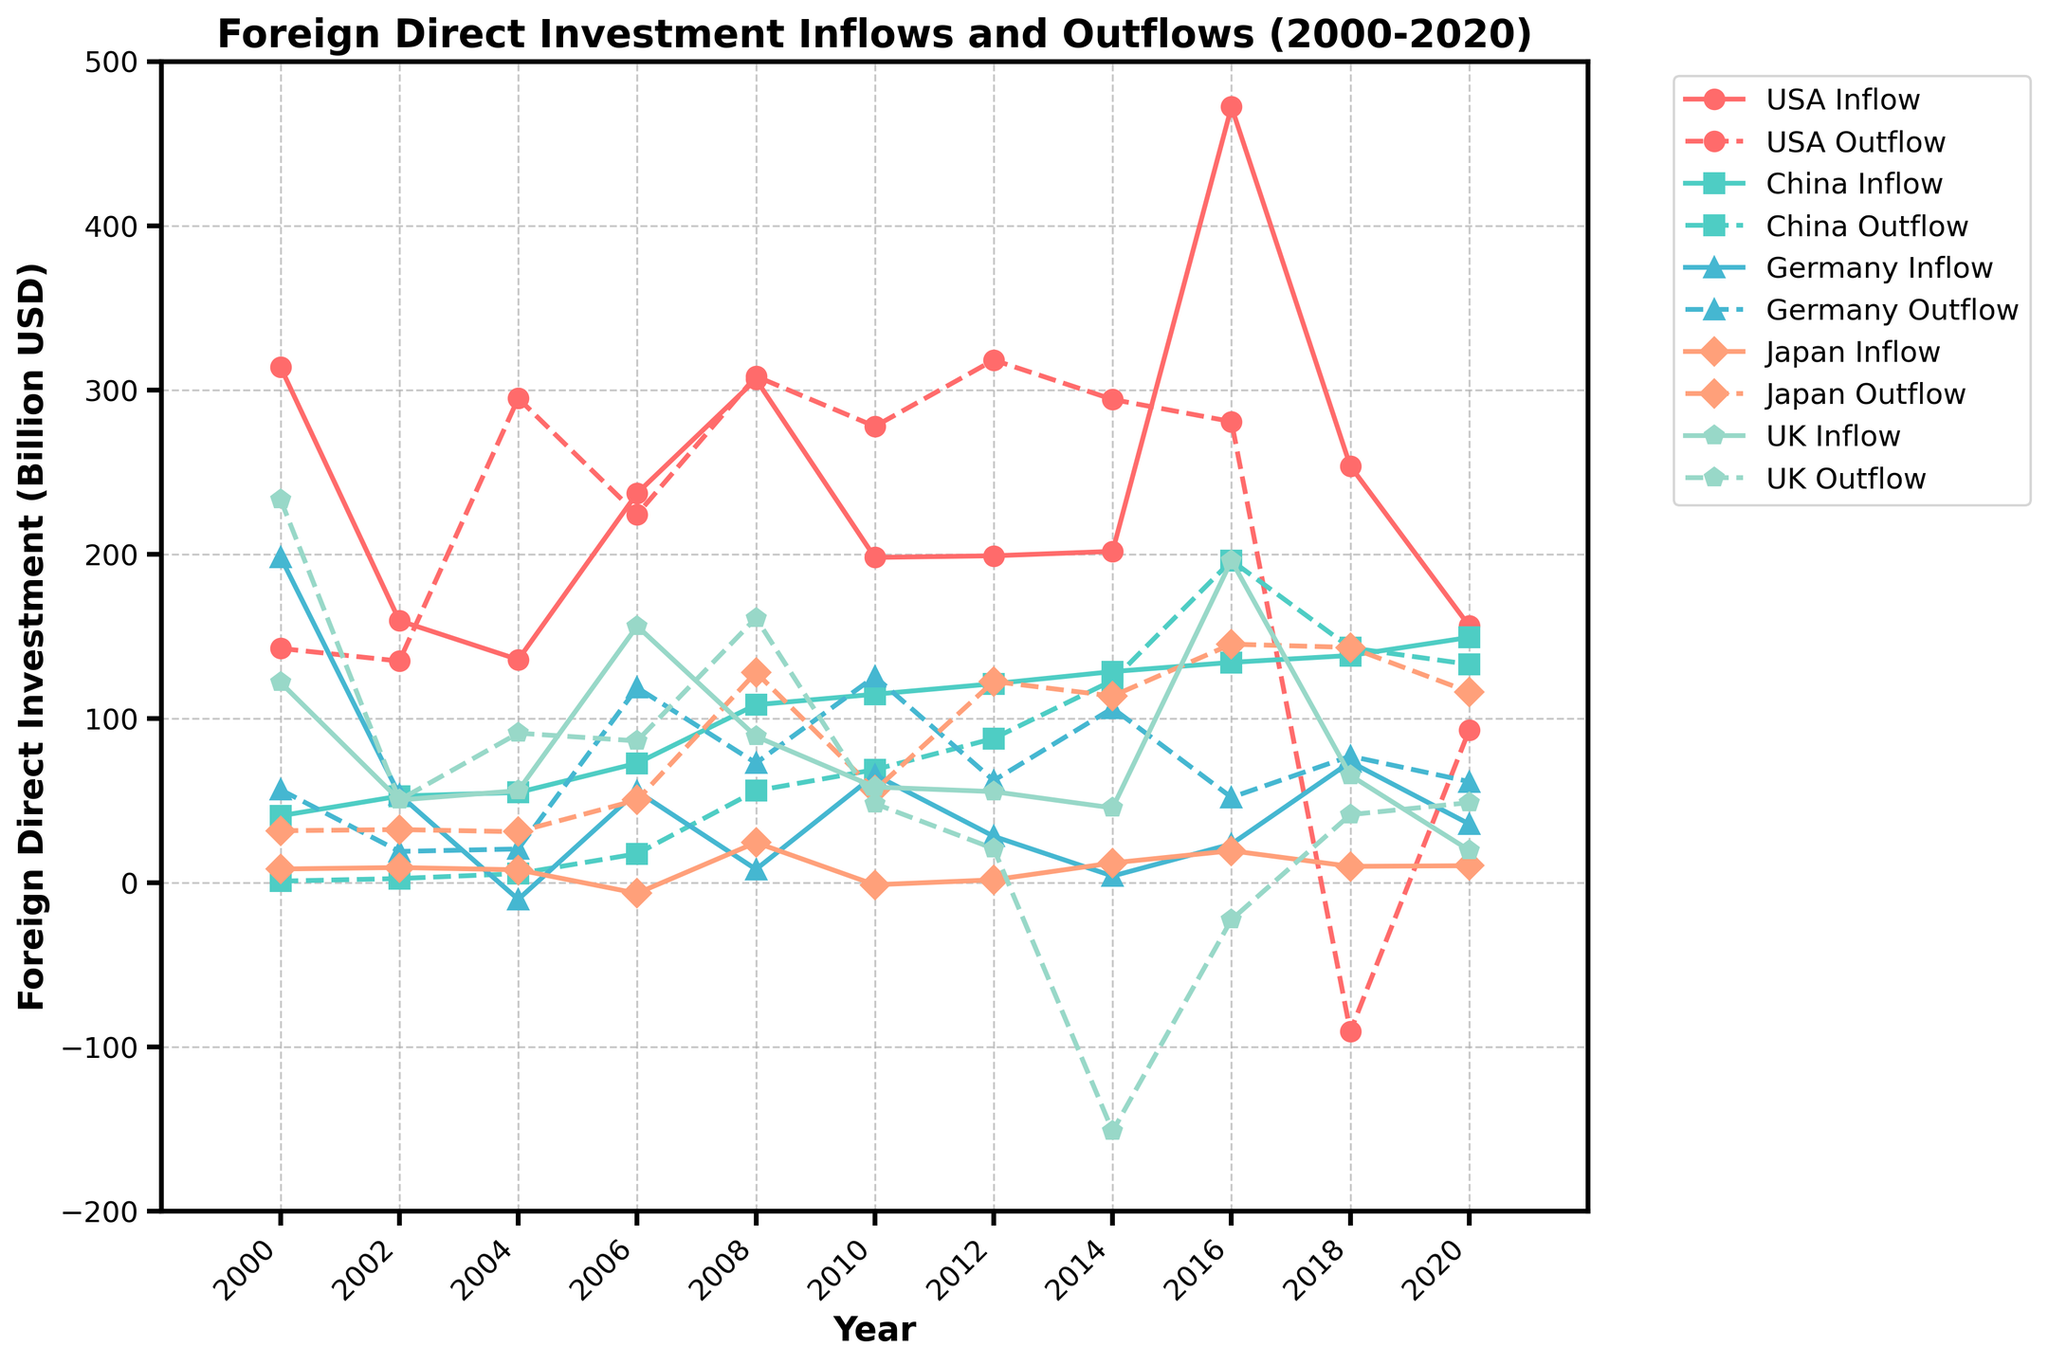What is the difference between the USA's FDI inflows and outflows in 2020? To find the difference between the USA's FDI inflows and outflows in 2020, we subtract the outflow value from the inflow value. Inflow is 156.3 Billion USD and outflow is 92.9 Billion USD. So, 156.3 - 92.9 = 63.4 Billion USD.
Answer: 63.4 Billion USD Which country had the highest FDI inflow in 2016? Looking at the 2016 data points, we compare the FDI inflows for each country: USA (472.4), China (134.1), Germany (23.5), Japan (19.4), and UK (196.1). The USA has the highest inflow with 472.4 Billion USD.
Answer: USA During which years did China have a higher outflow than inflow? We look for years where China's FDI outflow is greater than inflow by comparing values for each year: 
- In 2000 (0.9 < 40.7), the outflow is lower.
- In 2002 (2.5 < 52.7), the outflow is lower.
- In 2004 (5.5 < 54.9), the outflow is lower.
- In 2006 (17.6 < 72.7), the outflow is lower.
- In 2008 (55.9 < 108.3), the outflow is lower.
- In 2010 (68.8 < 114.7), the outflow is lower.
- In 2012 (87.8 < 121.1), the outflow is lower.
- In 2014 (123.1 < 128.5), the outflow is lower.
- In 2016 (196.1 > 134.1), the outflow is higher.
- In 2018 (143.0 > 138.3), the outflow is higher.
- In 2020 (132.9 < 149.3), the outflow is lower.
So, the years are 2016 and 2018.
Answer: 2016 and 2018 What is the average FDI inflow for Japan from 2000 to 2020? To find the average, we sum all the inflow values for Japan from 2000 to 2020 and divide by the total number of years (10):
(8.3 + 9.2 + 7.8 + -6.5 + 24.4 + -1.3 + 1.7 + 12.0 + 19.4 + 9.9 + 10.3) = 95.2. The average is 95.2 / 11 = 8.66 Billion USD.
Answer: 8.66 Billion USD In which year did the UK have a negative FDI outflow, and what was the value? By checking each year for negative outflow values for the UK, we find:
- In 2000, outflow is 233.4 (positive).
- In 2002, outflow is 50.3 (positive).
- In 2004, outflow is 91.0 (positive).
- In 2006, outflow is 86.3 (positive).
- In 2008, outflow is 161.1 (positive).
- In 2010, outflow is 48.1 (positive).
- In 2012, outflow is 20.7 (positive).
- In 2014, outflow is -151.3 (negative).
- In 2016, outflow is -22.5 (negative).
- In 2018, outflow is 41.4 (positive).
- In 2020, outflow is 48.7 (positive).
The years are 2014 and 2016, with values -151.3 Billion USD and -22.5 Billion USD respectively.
Answer: 2014 and 2016, -151.3 Billion USD and -22.5 Billion USD Comparing FDI inflows, how did Germany perform relative to China in 2008? To compare the inflows in 2008, we look at the data points: Germany's inflow is 8.1 Billion USD and China’s inflow is 108.3 Billion USD. China’s inflow is significantly higher than Germany’s.
Answer: China's inflow is higher What is the combined FDI outflow for Germany and Japan in 2014? To find the combined outflow, we sum the outflow values for Germany and Japan in 2014. Germany's outflow is 106.2 Billion USD and Japan's outflow is 113.6 Billion USD. So, 106.2 + 113.6 = 219.8 Billion USD.
Answer: 219.8 Billion USD 